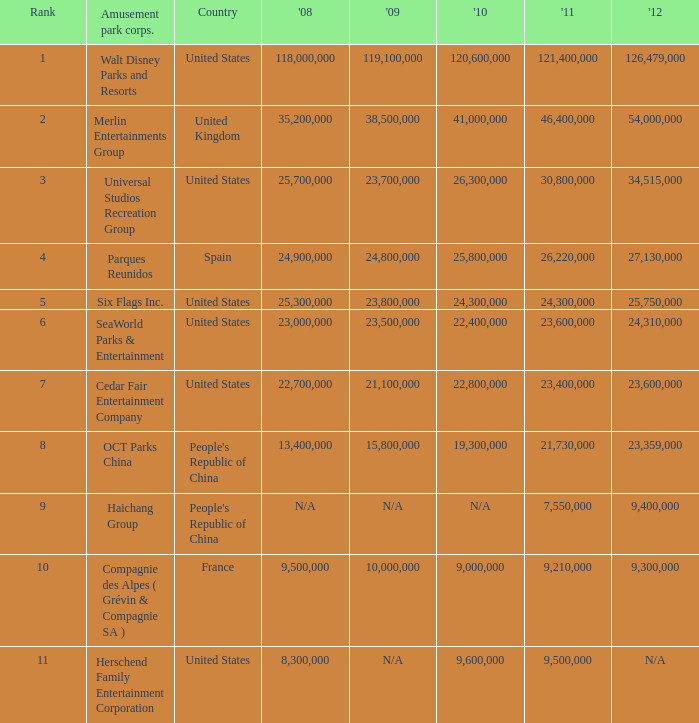In the United States the 2011 attendance at this amusement park corporation was larger than 30,800,000 but lists what as its 2008 attendance? 118000000.0. Write the full table. {'header': ['Rank', 'Amusement park corps.', 'Country', "'08", "'09", "'10", "'11", "'12"], 'rows': [['1', 'Walt Disney Parks and Resorts', 'United States', '118,000,000', '119,100,000', '120,600,000', '121,400,000', '126,479,000'], ['2', 'Merlin Entertainments Group', 'United Kingdom', '35,200,000', '38,500,000', '41,000,000', '46,400,000', '54,000,000'], ['3', 'Universal Studios Recreation Group', 'United States', '25,700,000', '23,700,000', '26,300,000', '30,800,000', '34,515,000'], ['4', 'Parques Reunidos', 'Spain', '24,900,000', '24,800,000', '25,800,000', '26,220,000', '27,130,000'], ['5', 'Six Flags Inc.', 'United States', '25,300,000', '23,800,000', '24,300,000', '24,300,000', '25,750,000'], ['6', 'SeaWorld Parks & Entertainment', 'United States', '23,000,000', '23,500,000', '22,400,000', '23,600,000', '24,310,000'], ['7', 'Cedar Fair Entertainment Company', 'United States', '22,700,000', '21,100,000', '22,800,000', '23,400,000', '23,600,000'], ['8', 'OCT Parks China', "People's Republic of China", '13,400,000', '15,800,000', '19,300,000', '21,730,000', '23,359,000'], ['9', 'Haichang Group', "People's Republic of China", 'N/A', 'N/A', 'N/A', '7,550,000', '9,400,000'], ['10', 'Compagnie des Alpes ( Grévin & Compagnie SA )', 'France', '9,500,000', '10,000,000', '9,000,000', '9,210,000', '9,300,000'], ['11', 'Herschend Family Entertainment Corporation', 'United States', '8,300,000', 'N/A', '9,600,000', '9,500,000', 'N/A']]} 